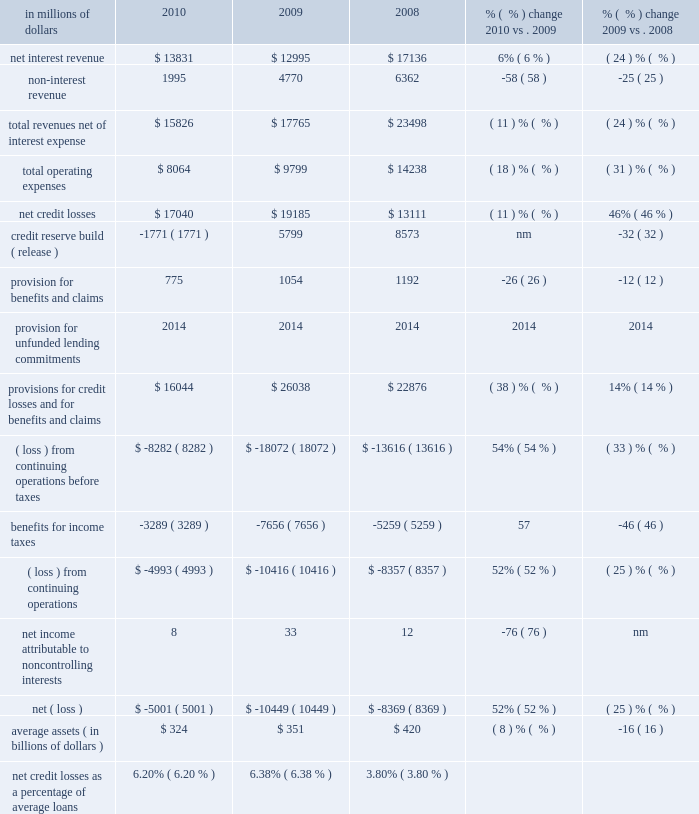Local consumer lending local consumer lending ( lcl ) , which constituted approximately 70% ( 70 % ) of citi holdings by assets as of december 31 , 2010 , includes a portion of citigroup 2019s north american mortgage business , retail partner cards , western european cards and retail banking , citifinancial north america and other local consumer finance businesses globally .
The student loan corporation is reported as discontinued operations within the corporate/other segment for the second half of 2010 only .
At december 31 , 2010 , lcl had $ 252 billion of assets ( $ 226 billion in north america ) .
Approximately $ 129 billion of assets in lcl as of december 31 , 2010 consisted of u.s .
Mortgages in the company 2019s citimortgage and citifinancial operations .
The north american assets consist of residential mortgage loans ( first and second mortgages ) , retail partner card loans , personal loans , commercial real estate ( cre ) , and other consumer loans and assets .
In millions of dollars 2010 2009 2008 % (  % ) change 2010 vs .
2009 % (  % ) change 2009 vs .
2008 .
Nm not meaningful 2010 vs .
2009 revenues , net of interest expense decreased 11% ( 11 % ) from the prior year .
Net interest revenue increased 6% ( 6 % ) due to the adoption of sfas 166/167 , partially offset by the impact of lower balances due to portfolio run-off and asset sales .
Non-interest revenue declined 58% ( 58 % ) , primarily due to the absence of the $ 1.1 billion gain on the sale of redecard in the first quarter of 2009 and a higher mortgage repurchase reserve charge .
Operating expenses decreased 18% ( 18 % ) , primarily due to the impact of divestitures , lower volumes , re-engineering actions and the absence of costs associated with the u.s .
Government loss-sharing agreement , which was exited in the fourth quarter of 2009 .
Provisions for credit losses and for benefits and claims decreased 38% ( 38 % ) , reflecting a net $ 1.8 billion credit reserve release in 2010 compared to a $ 5.8 billion build in 2009 .
Lower net credit losses across most businesses were partially offset by the impact of the adoption of sfas 166/167 .
On a comparable basis , net credit losses were lower year-over-year , driven by improvement in u.s .
Mortgages , international portfolios and retail partner cards .
Assets declined 21% ( 21 % ) from the prior year , primarily driven by portfolio run-off , higher loan loss reserve balances , and the impact of asset sales and divestitures , partially offset by an increase of $ 41 billion resulting from the adoption of sfas 166/167 .
Key divestitures in 2010 included the student loan corporation , primerica , auto loans , the canadian mastercard business and u.s .
Retail sales finance portfolios .
2009 vs .
2008 revenues , net of interest expense decreased 24% ( 24 % ) from the prior year .
Net interest revenue was 24% ( 24 % ) lower than the prior year , primarily due to lower balances , de-risking of the portfolio , and spread compression .
Non-interest revenue decreased $ 1.6 billion , mostly driven by the impact of higher credit losses flowing through the securitization trusts , partially offset by the $ 1.1 billion gain on the sale of redecard in the first quarter of 2009 .
Operating expenses declined 31% ( 31 % ) from the prior year , due to lower volumes and reductions from expense re-engineering actions , and the impact of goodwill write-offs of $ 3.0 billion in the fourth quarter of 2008 , partially offset by higher costs associated with delinquent loans .
Provisions for credit losses and for benefits and claims increased 14% ( 14 % ) from the prior year , reflecting an increase in net credit losses of $ 6.1 billion , partially offset by lower reserve builds of $ 2.8 billion .
Higher net credit losses were primarily driven by higher losses of $ 3.6 billion in residential real estate lending , $ 1.0 billion in retail partner cards , and $ 0.7 billion in international .
Assets decreased $ 57 billion from the prior year , primarily driven by lower originations , wind-down of specific businesses , asset sales , divestitures , write- offs and higher loan loss reserve balances .
Key divestitures in 2009 included the fi credit card business , italy consumer finance , diners europe , portugal cards , norway consumer and diners club north america. .
What percentage of total revenues net of interest expense where net interest revenues in 2010? 
Computations: (13831 / 15826)
Answer: 0.87394. Local consumer lending local consumer lending ( lcl ) , which constituted approximately 70% ( 70 % ) of citi holdings by assets as of december 31 , 2010 , includes a portion of citigroup 2019s north american mortgage business , retail partner cards , western european cards and retail banking , citifinancial north america and other local consumer finance businesses globally .
The student loan corporation is reported as discontinued operations within the corporate/other segment for the second half of 2010 only .
At december 31 , 2010 , lcl had $ 252 billion of assets ( $ 226 billion in north america ) .
Approximately $ 129 billion of assets in lcl as of december 31 , 2010 consisted of u.s .
Mortgages in the company 2019s citimortgage and citifinancial operations .
The north american assets consist of residential mortgage loans ( first and second mortgages ) , retail partner card loans , personal loans , commercial real estate ( cre ) , and other consumer loans and assets .
In millions of dollars 2010 2009 2008 % (  % ) change 2010 vs .
2009 % (  % ) change 2009 vs .
2008 .
Nm not meaningful 2010 vs .
2009 revenues , net of interest expense decreased 11% ( 11 % ) from the prior year .
Net interest revenue increased 6% ( 6 % ) due to the adoption of sfas 166/167 , partially offset by the impact of lower balances due to portfolio run-off and asset sales .
Non-interest revenue declined 58% ( 58 % ) , primarily due to the absence of the $ 1.1 billion gain on the sale of redecard in the first quarter of 2009 and a higher mortgage repurchase reserve charge .
Operating expenses decreased 18% ( 18 % ) , primarily due to the impact of divestitures , lower volumes , re-engineering actions and the absence of costs associated with the u.s .
Government loss-sharing agreement , which was exited in the fourth quarter of 2009 .
Provisions for credit losses and for benefits and claims decreased 38% ( 38 % ) , reflecting a net $ 1.8 billion credit reserve release in 2010 compared to a $ 5.8 billion build in 2009 .
Lower net credit losses across most businesses were partially offset by the impact of the adoption of sfas 166/167 .
On a comparable basis , net credit losses were lower year-over-year , driven by improvement in u.s .
Mortgages , international portfolios and retail partner cards .
Assets declined 21% ( 21 % ) from the prior year , primarily driven by portfolio run-off , higher loan loss reserve balances , and the impact of asset sales and divestitures , partially offset by an increase of $ 41 billion resulting from the adoption of sfas 166/167 .
Key divestitures in 2010 included the student loan corporation , primerica , auto loans , the canadian mastercard business and u.s .
Retail sales finance portfolios .
2009 vs .
2008 revenues , net of interest expense decreased 24% ( 24 % ) from the prior year .
Net interest revenue was 24% ( 24 % ) lower than the prior year , primarily due to lower balances , de-risking of the portfolio , and spread compression .
Non-interest revenue decreased $ 1.6 billion , mostly driven by the impact of higher credit losses flowing through the securitization trusts , partially offset by the $ 1.1 billion gain on the sale of redecard in the first quarter of 2009 .
Operating expenses declined 31% ( 31 % ) from the prior year , due to lower volumes and reductions from expense re-engineering actions , and the impact of goodwill write-offs of $ 3.0 billion in the fourth quarter of 2008 , partially offset by higher costs associated with delinquent loans .
Provisions for credit losses and for benefits and claims increased 14% ( 14 % ) from the prior year , reflecting an increase in net credit losses of $ 6.1 billion , partially offset by lower reserve builds of $ 2.8 billion .
Higher net credit losses were primarily driven by higher losses of $ 3.6 billion in residential real estate lending , $ 1.0 billion in retail partner cards , and $ 0.7 billion in international .
Assets decreased $ 57 billion from the prior year , primarily driven by lower originations , wind-down of specific businesses , asset sales , divestitures , write- offs and higher loan loss reserve balances .
Key divestitures in 2009 included the fi credit card business , italy consumer finance , diners europe , portugal cards , norway consumer and diners club north america. .
What percentage of total revenues net of interest expense where net interest revenues in 2009? 
Computations: (12995 / 17765)
Answer: 0.73149. 